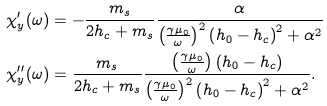Convert formula to latex. <formula><loc_0><loc_0><loc_500><loc_500>\chi _ { y } ^ { \prime } ( \omega ) & = - \frac { m _ { s } } { 2 h _ { c } + m _ { s } } \frac { \alpha } { \left ( \frac { \gamma \mu _ { 0 } } { \omega } \right ) ^ { 2 } \left ( h _ { 0 } - h _ { c } \right ) ^ { 2 } + \alpha ^ { 2 } } \\ \chi _ { y } ^ { \prime \prime } ( \omega ) & = \frac { m _ { s } } { 2 h _ { c } + m _ { s } } \frac { \left ( \frac { \gamma \mu _ { 0 } } { \omega } \right ) \left ( h _ { 0 } - h _ { c } \right ) } { \left ( \frac { \gamma \mu _ { 0 } } { \omega } \right ) ^ { 2 } \left ( h _ { 0 } - h _ { c } \right ) ^ { 2 } + \alpha ^ { 2 } } \text {.}</formula> 